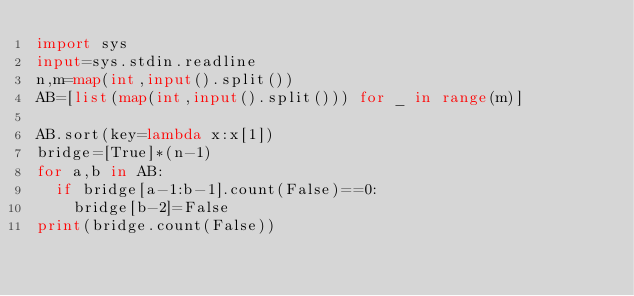Convert code to text. <code><loc_0><loc_0><loc_500><loc_500><_Python_>import sys
input=sys.stdin.readline
n,m=map(int,input().split())
AB=[list(map(int,input().split())) for _ in range(m)]

AB.sort(key=lambda x:x[1])
bridge=[True]*(n-1)
for a,b in AB:
  if bridge[a-1:b-1].count(False)==0:
    bridge[b-2]=False
print(bridge.count(False))</code> 